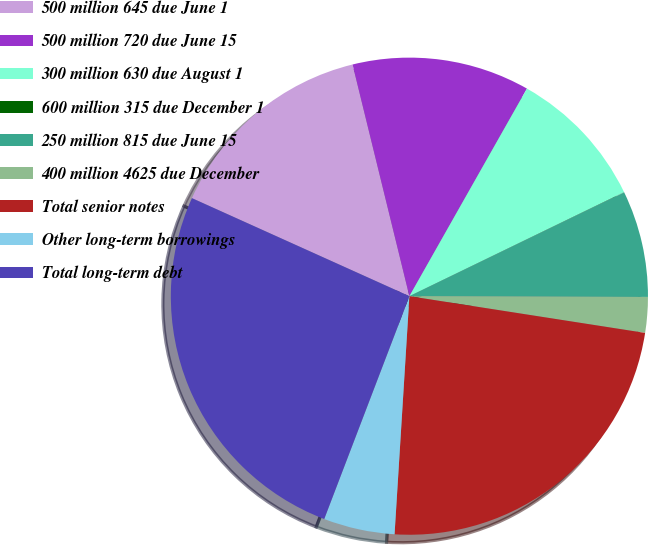Convert chart. <chart><loc_0><loc_0><loc_500><loc_500><pie_chart><fcel>500 million 645 due June 1<fcel>500 million 720 due June 15<fcel>300 million 630 due August 1<fcel>600 million 315 due December 1<fcel>250 million 815 due June 15<fcel>400 million 4625 due December<fcel>Total senior notes<fcel>Other long-term borrowings<fcel>Total long-term debt<nl><fcel>14.43%<fcel>12.03%<fcel>9.62%<fcel>0.01%<fcel>7.22%<fcel>2.41%<fcel>23.53%<fcel>4.82%<fcel>25.93%<nl></chart> 